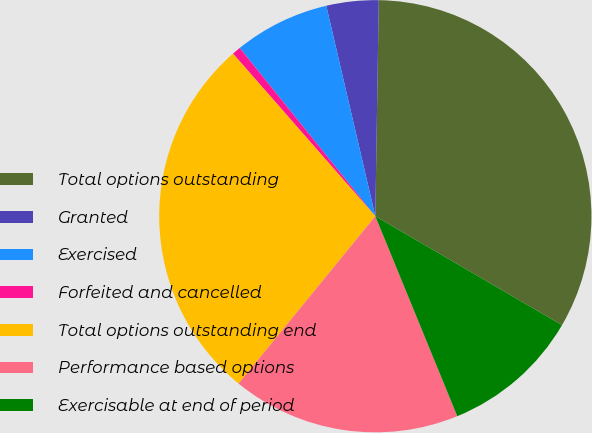Convert chart to OTSL. <chart><loc_0><loc_0><loc_500><loc_500><pie_chart><fcel>Total options outstanding<fcel>Granted<fcel>Exercised<fcel>Forfeited and cancelled<fcel>Total options outstanding end<fcel>Performance based options<fcel>Exercisable at end of period<nl><fcel>33.15%<fcel>3.9%<fcel>7.15%<fcel>0.65%<fcel>27.65%<fcel>17.09%<fcel>10.4%<nl></chart> 